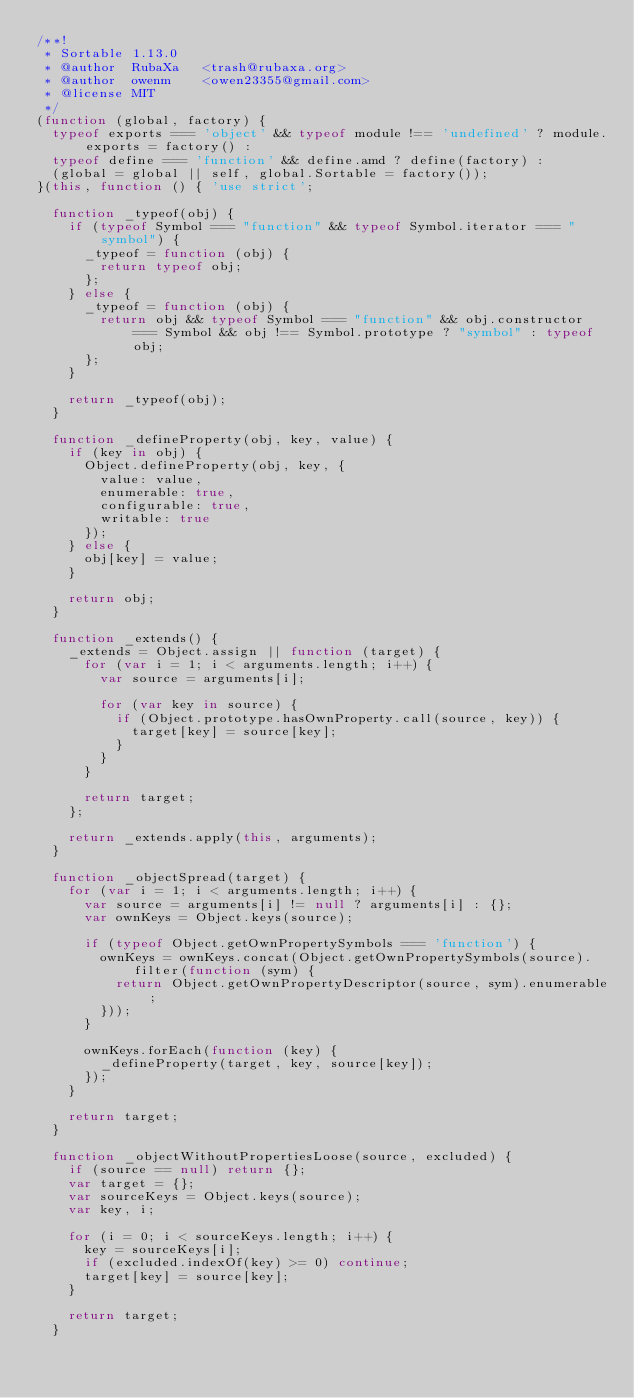<code> <loc_0><loc_0><loc_500><loc_500><_JavaScript_>/**!
 * Sortable 1.13.0
 * @author	RubaXa   <trash@rubaxa.org>
 * @author	owenm    <owen23355@gmail.com>
 * @license MIT
 */
(function (global, factory) {
  typeof exports === 'object' && typeof module !== 'undefined' ? module.exports = factory() :
  typeof define === 'function' && define.amd ? define(factory) :
  (global = global || self, global.Sortable = factory());
}(this, function () { 'use strict';

  function _typeof(obj) {
    if (typeof Symbol === "function" && typeof Symbol.iterator === "symbol") {
      _typeof = function (obj) {
        return typeof obj;
      };
    } else {
      _typeof = function (obj) {
        return obj && typeof Symbol === "function" && obj.constructor === Symbol && obj !== Symbol.prototype ? "symbol" : typeof obj;
      };
    }

    return _typeof(obj);
  }

  function _defineProperty(obj, key, value) {
    if (key in obj) {
      Object.defineProperty(obj, key, {
        value: value,
        enumerable: true,
        configurable: true,
        writable: true
      });
    } else {
      obj[key] = value;
    }

    return obj;
  }

  function _extends() {
    _extends = Object.assign || function (target) {
      for (var i = 1; i < arguments.length; i++) {
        var source = arguments[i];

        for (var key in source) {
          if (Object.prototype.hasOwnProperty.call(source, key)) {
            target[key] = source[key];
          }
        }
      }

      return target;
    };

    return _extends.apply(this, arguments);
  }

  function _objectSpread(target) {
    for (var i = 1; i < arguments.length; i++) {
      var source = arguments[i] != null ? arguments[i] : {};
      var ownKeys = Object.keys(source);

      if (typeof Object.getOwnPropertySymbols === 'function') {
        ownKeys = ownKeys.concat(Object.getOwnPropertySymbols(source).filter(function (sym) {
          return Object.getOwnPropertyDescriptor(source, sym).enumerable;
        }));
      }

      ownKeys.forEach(function (key) {
        _defineProperty(target, key, source[key]);
      });
    }

    return target;
  }

  function _objectWithoutPropertiesLoose(source, excluded) {
    if (source == null) return {};
    var target = {};
    var sourceKeys = Object.keys(source);
    var key, i;

    for (i = 0; i < sourceKeys.length; i++) {
      key = sourceKeys[i];
      if (excluded.indexOf(key) >= 0) continue;
      target[key] = source[key];
    }

    return target;
  }
</code> 